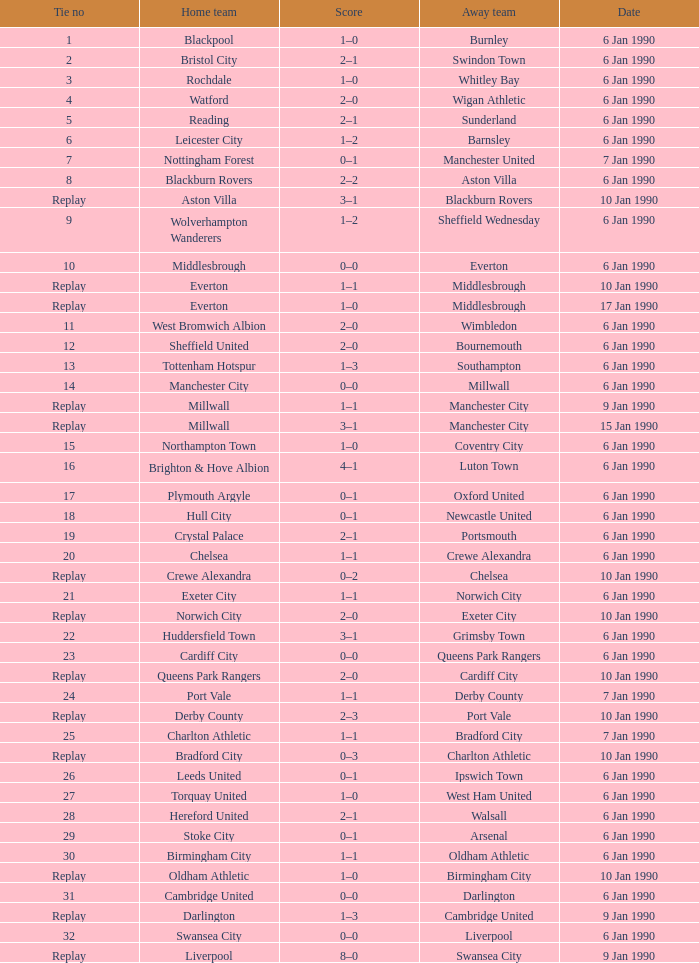What is the tie no of the game where exeter city was the home team? 21.0. 